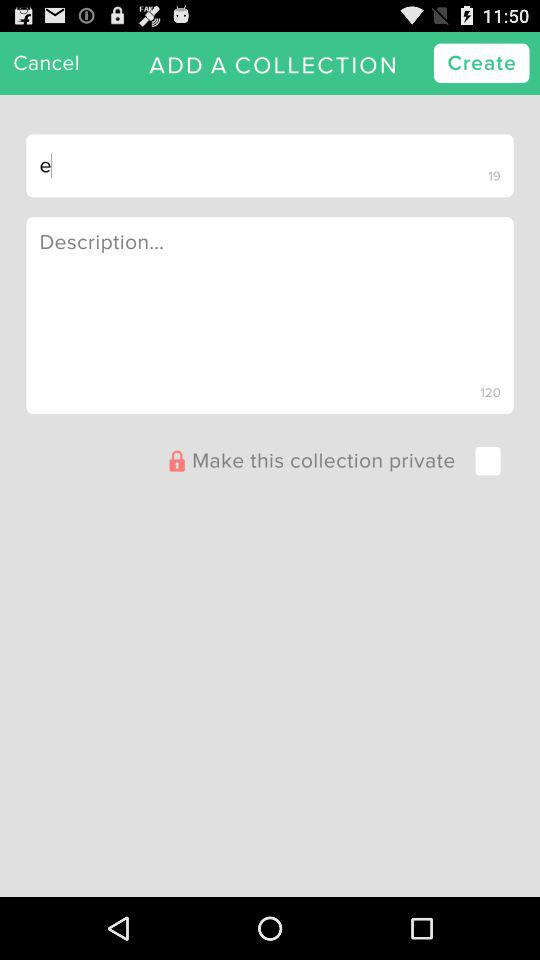What is the selected tab?
When the provided information is insufficient, respond with <no answer>. <no answer> 